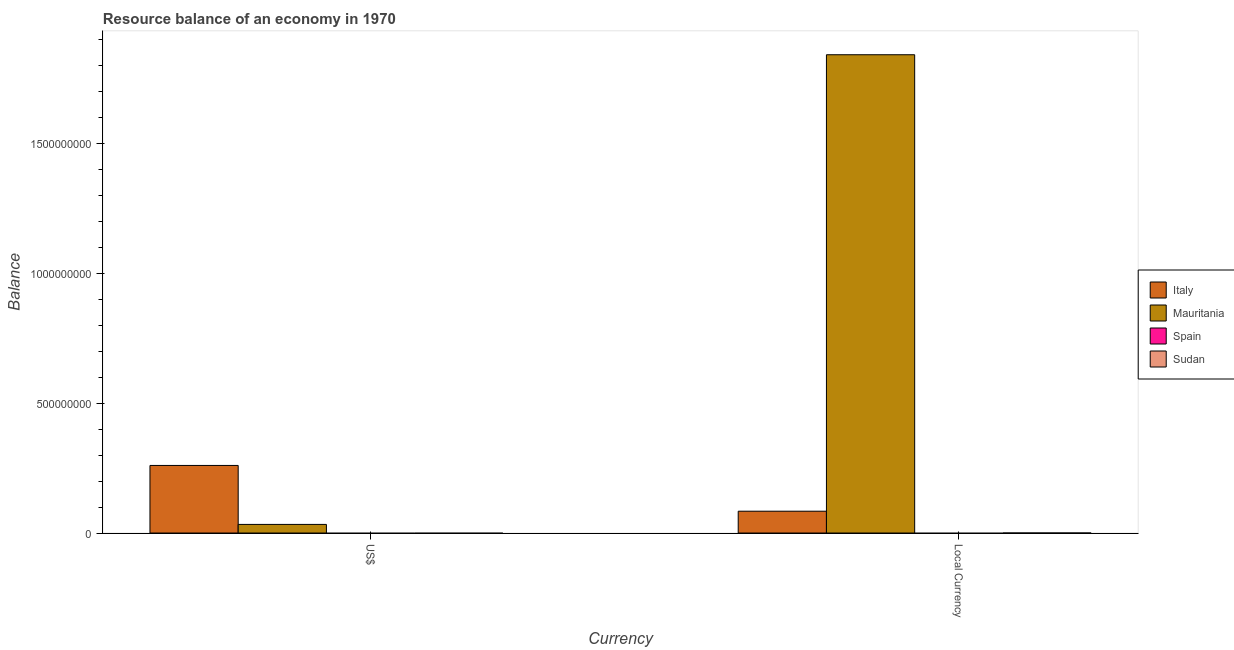Are the number of bars per tick equal to the number of legend labels?
Your answer should be very brief. No. How many bars are there on the 2nd tick from the left?
Give a very brief answer. 2. How many bars are there on the 2nd tick from the right?
Offer a very short reply. 2. What is the label of the 1st group of bars from the left?
Make the answer very short. US$. What is the resource balance in us$ in Sudan?
Make the answer very short. 0. Across all countries, what is the maximum resource balance in us$?
Provide a short and direct response. 2.60e+08. In which country was the resource balance in us$ maximum?
Your answer should be compact. Italy. What is the total resource balance in constant us$ in the graph?
Offer a terse response. 1.93e+09. What is the difference between the resource balance in us$ in Italy and the resource balance in constant us$ in Mauritania?
Your answer should be compact. -1.58e+09. What is the average resource balance in constant us$ per country?
Offer a terse response. 4.82e+08. What is the difference between the resource balance in us$ and resource balance in constant us$ in Mauritania?
Ensure brevity in your answer.  -1.81e+09. What is the ratio of the resource balance in us$ in Italy to that in Mauritania?
Your answer should be compact. 7.85. How many bars are there?
Offer a terse response. 4. Are all the bars in the graph horizontal?
Your response must be concise. No. How many countries are there in the graph?
Your response must be concise. 4. Are the values on the major ticks of Y-axis written in scientific E-notation?
Your response must be concise. No. Does the graph contain any zero values?
Your response must be concise. Yes. Does the graph contain grids?
Keep it short and to the point. No. Where does the legend appear in the graph?
Keep it short and to the point. Center right. How are the legend labels stacked?
Ensure brevity in your answer.  Vertical. What is the title of the graph?
Offer a terse response. Resource balance of an economy in 1970. What is the label or title of the X-axis?
Keep it short and to the point. Currency. What is the label or title of the Y-axis?
Make the answer very short. Balance. What is the Balance of Italy in US$?
Your response must be concise. 2.60e+08. What is the Balance in Mauritania in US$?
Your response must be concise. 3.32e+07. What is the Balance of Spain in US$?
Ensure brevity in your answer.  0. What is the Balance in Italy in Local Currency?
Offer a terse response. 8.41e+07. What is the Balance in Mauritania in Local Currency?
Your answer should be very brief. 1.84e+09. Across all Currency, what is the maximum Balance of Italy?
Provide a succinct answer. 2.60e+08. Across all Currency, what is the maximum Balance of Mauritania?
Offer a terse response. 1.84e+09. Across all Currency, what is the minimum Balance of Italy?
Ensure brevity in your answer.  8.41e+07. Across all Currency, what is the minimum Balance in Mauritania?
Offer a terse response. 3.32e+07. What is the total Balance in Italy in the graph?
Ensure brevity in your answer.  3.45e+08. What is the total Balance in Mauritania in the graph?
Your answer should be very brief. 1.88e+09. What is the total Balance in Spain in the graph?
Provide a short and direct response. 0. What is the difference between the Balance in Italy in US$ and that in Local Currency?
Make the answer very short. 1.76e+08. What is the difference between the Balance of Mauritania in US$ and that in Local Currency?
Provide a short and direct response. -1.81e+09. What is the difference between the Balance in Italy in US$ and the Balance in Mauritania in Local Currency?
Keep it short and to the point. -1.58e+09. What is the average Balance of Italy per Currency?
Your response must be concise. 1.72e+08. What is the average Balance in Mauritania per Currency?
Provide a short and direct response. 9.38e+08. What is the average Balance of Spain per Currency?
Your answer should be compact. 0. What is the average Balance of Sudan per Currency?
Your answer should be very brief. 0. What is the difference between the Balance in Italy and Balance in Mauritania in US$?
Give a very brief answer. 2.27e+08. What is the difference between the Balance in Italy and Balance in Mauritania in Local Currency?
Provide a succinct answer. -1.76e+09. What is the ratio of the Balance in Italy in US$ to that in Local Currency?
Provide a succinct answer. 3.1. What is the ratio of the Balance of Mauritania in US$ to that in Local Currency?
Keep it short and to the point. 0.02. What is the difference between the highest and the second highest Balance of Italy?
Offer a terse response. 1.76e+08. What is the difference between the highest and the second highest Balance of Mauritania?
Offer a very short reply. 1.81e+09. What is the difference between the highest and the lowest Balance in Italy?
Keep it short and to the point. 1.76e+08. What is the difference between the highest and the lowest Balance of Mauritania?
Offer a terse response. 1.81e+09. 